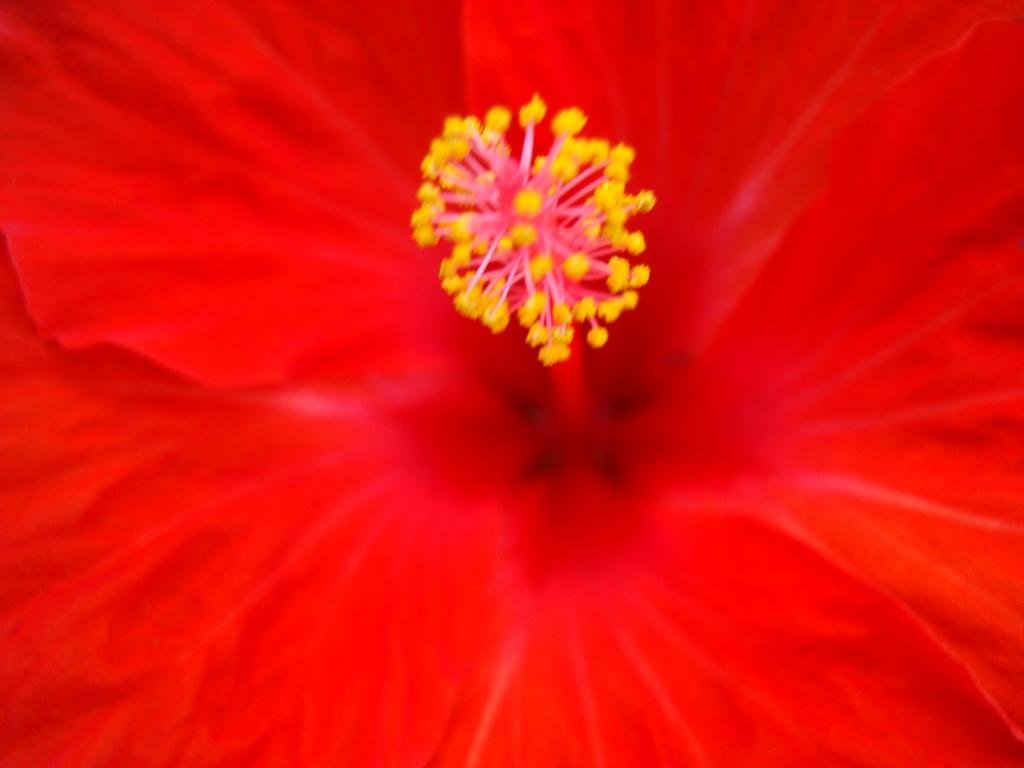What type of flower is in the picture? There is a red flower in the picture. What color are the petals of the flower? The flower has red petals. What can be found on the flower's stamen? The flower has pollen grains. What unit of measurement is used to determine the size of the prison in the image? There is no prison present in the image, so it is not possible to determine the unit of measurement used to determine its size. 